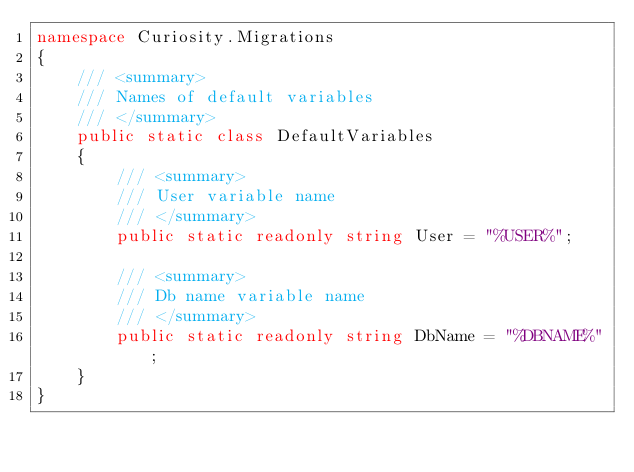Convert code to text. <code><loc_0><loc_0><loc_500><loc_500><_C#_>namespace Curiosity.Migrations
{
    /// <summary>
    /// Names of default variables 
    /// </summary>
    public static class DefaultVariables
    {
        /// <summary>
        /// User variable name
        /// </summary>
        public static readonly string User = "%USER%";

        /// <summary>
        /// Db name variable name
        /// </summary>
        public static readonly string DbName = "%DBNAME%";
    }
}</code> 